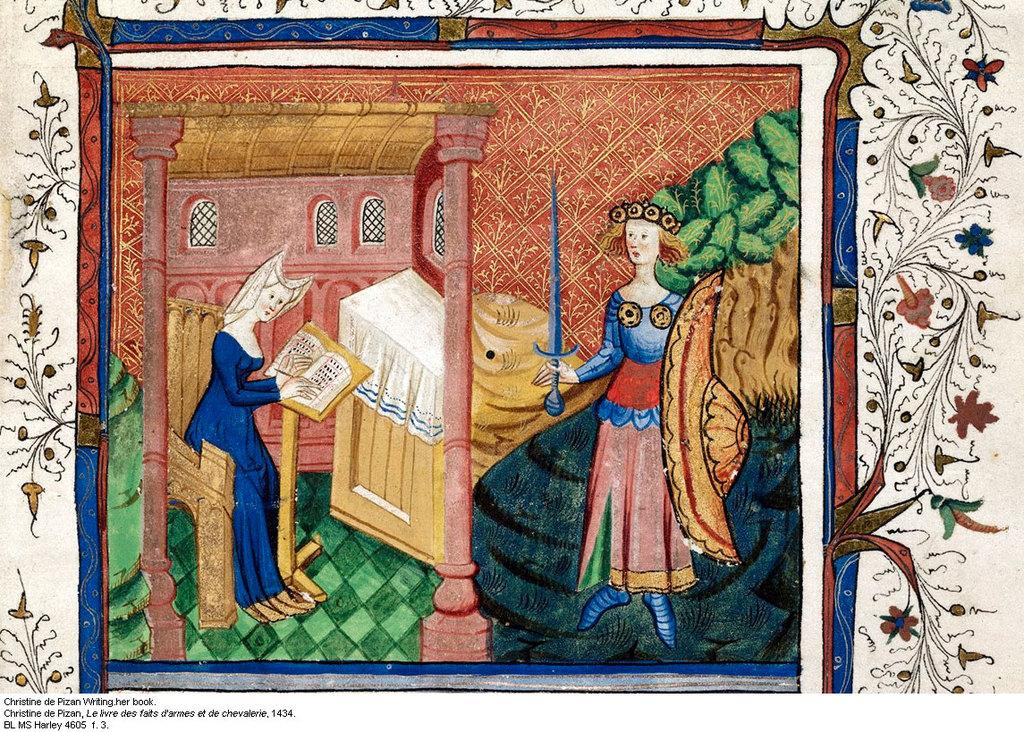What is the main subject of the image? The main subject of the image is a painting. What can be seen in the painting? The painting contains two persons, a house, a tree, and some designs. Is there any text present in the image? Yes, there is text on the image. How many cherries are hanging from the tree in the painting? There are no cherries present in the painting; it contains a tree but no specific fruit. What type of ornament is hanging from the house in the painting? There is no ornament hanging from the house in the painting; it only contains a house and other elements mentioned earlier. 